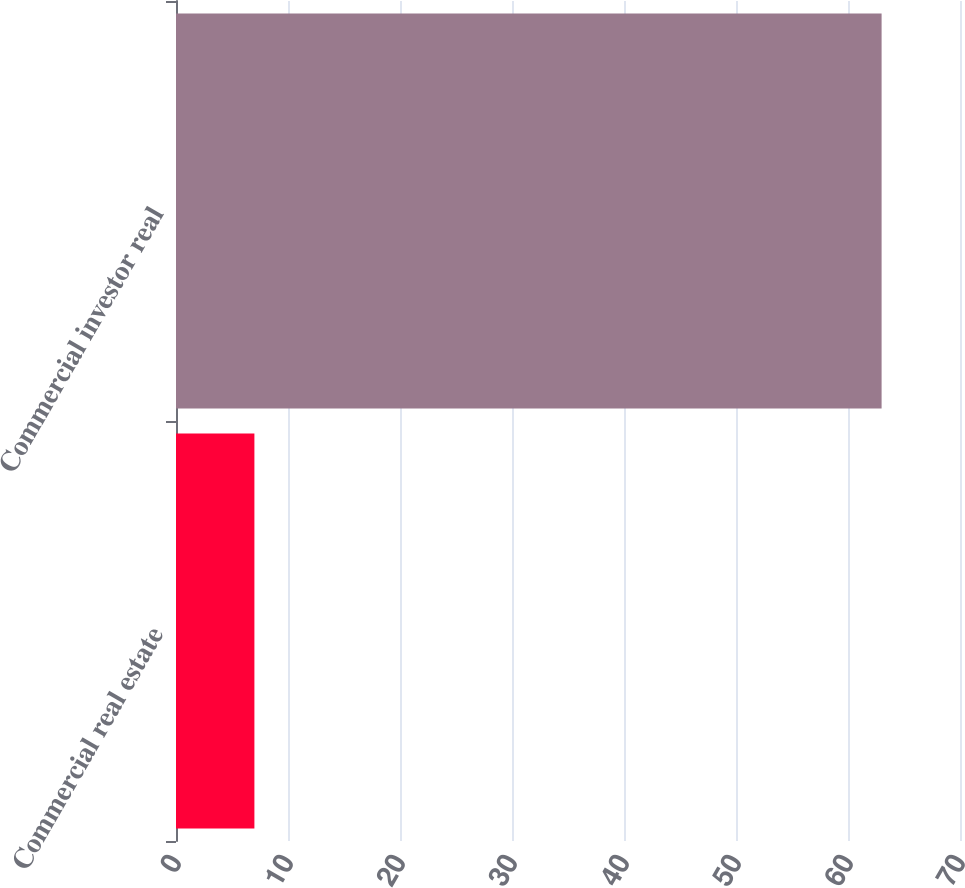<chart> <loc_0><loc_0><loc_500><loc_500><bar_chart><fcel>Commercial real estate<fcel>Commercial investor real<nl><fcel>7<fcel>63<nl></chart> 